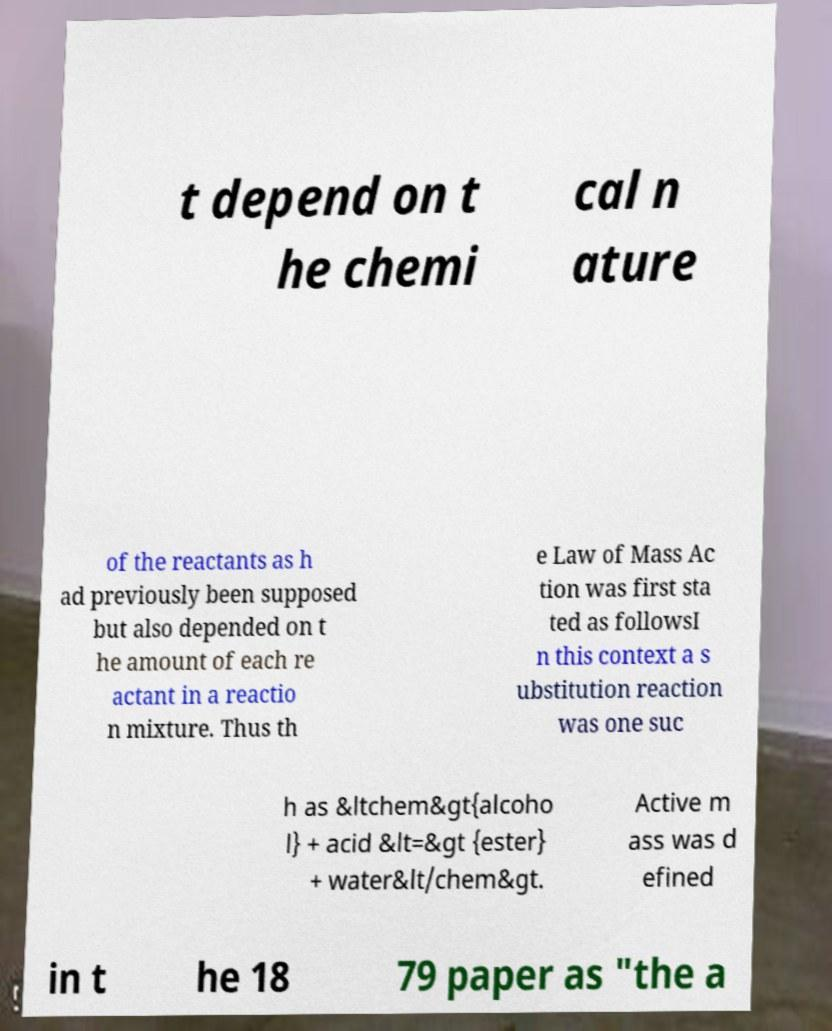I need the written content from this picture converted into text. Can you do that? t depend on t he chemi cal n ature of the reactants as h ad previously been supposed but also depended on t he amount of each re actant in a reactio n mixture. Thus th e Law of Mass Ac tion was first sta ted as followsI n this context a s ubstitution reaction was one suc h as &ltchem&gt{alcoho l} + acid &lt=&gt {ester} + water&lt/chem&gt. Active m ass was d efined in t he 18 79 paper as "the a 